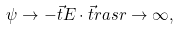<formula> <loc_0><loc_0><loc_500><loc_500>\psi \rightarrow - \vec { t } { E } \cdot \vec { t } { r } a s r \rightarrow \infty ,</formula> 